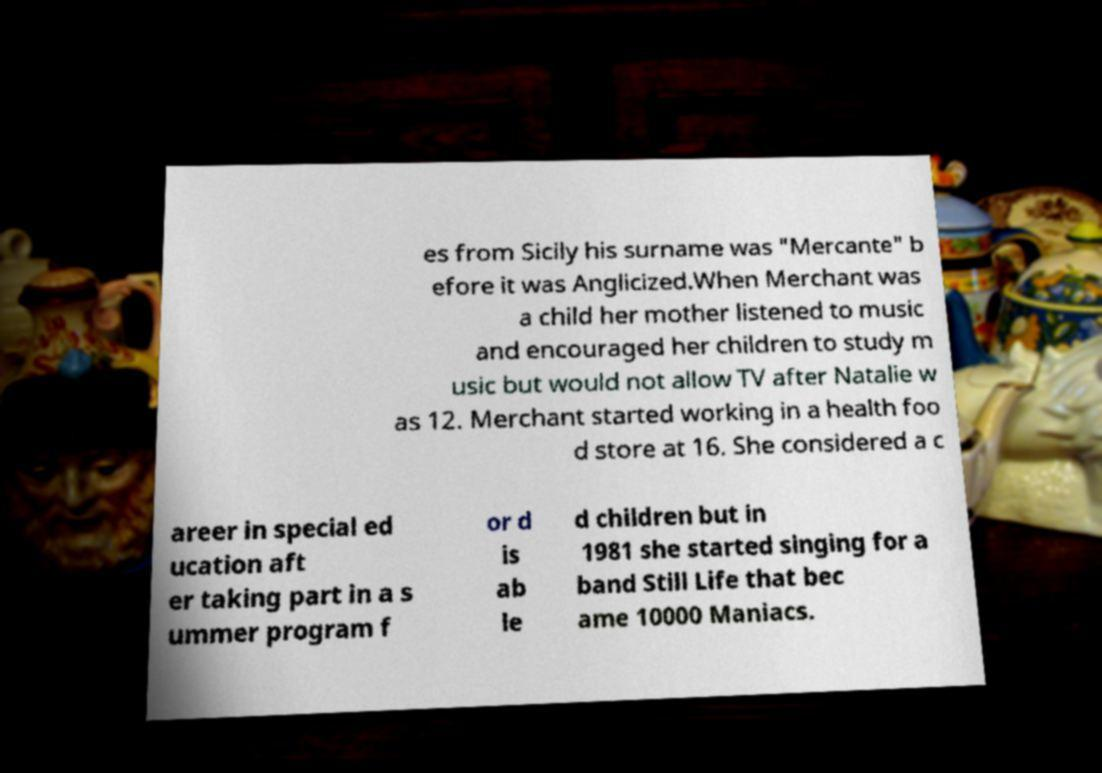Please read and relay the text visible in this image. What does it say? es from Sicily his surname was "Mercante" b efore it was Anglicized.When Merchant was a child her mother listened to music and encouraged her children to study m usic but would not allow TV after Natalie w as 12. Merchant started working in a health foo d store at 16. She considered a c areer in special ed ucation aft er taking part in a s ummer program f or d is ab le d children but in 1981 she started singing for a band Still Life that bec ame 10000 Maniacs. 